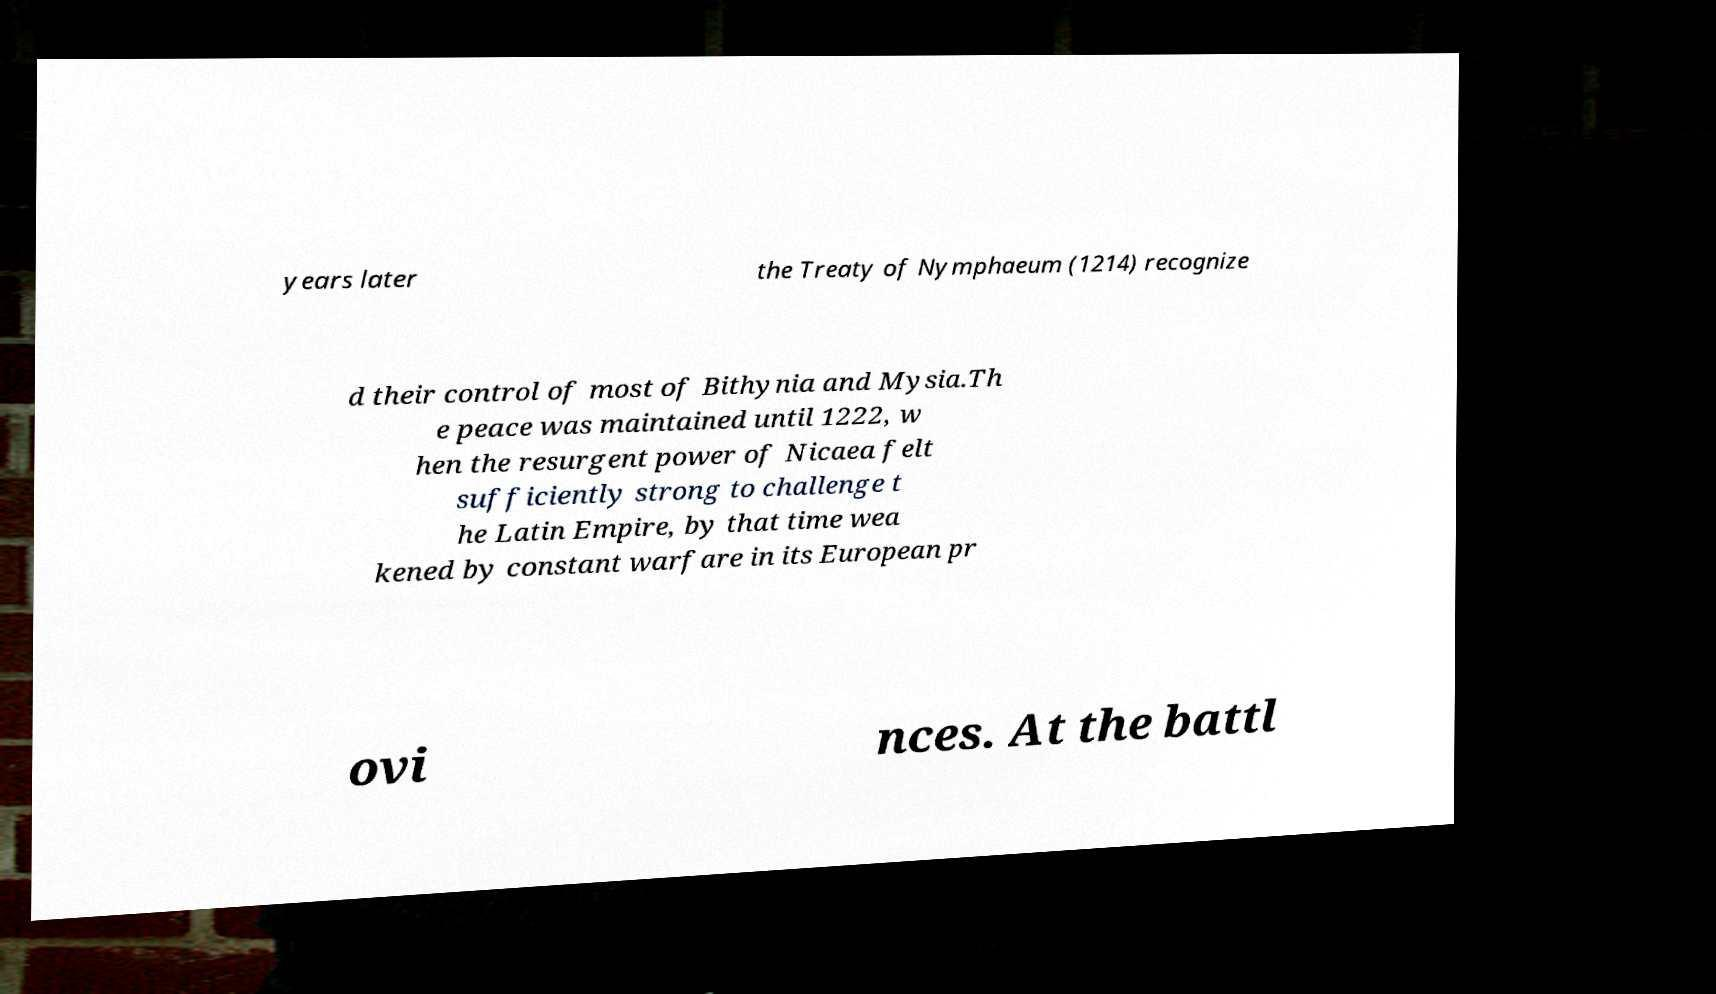Please identify and transcribe the text found in this image. years later the Treaty of Nymphaeum (1214) recognize d their control of most of Bithynia and Mysia.Th e peace was maintained until 1222, w hen the resurgent power of Nicaea felt sufficiently strong to challenge t he Latin Empire, by that time wea kened by constant warfare in its European pr ovi nces. At the battl 